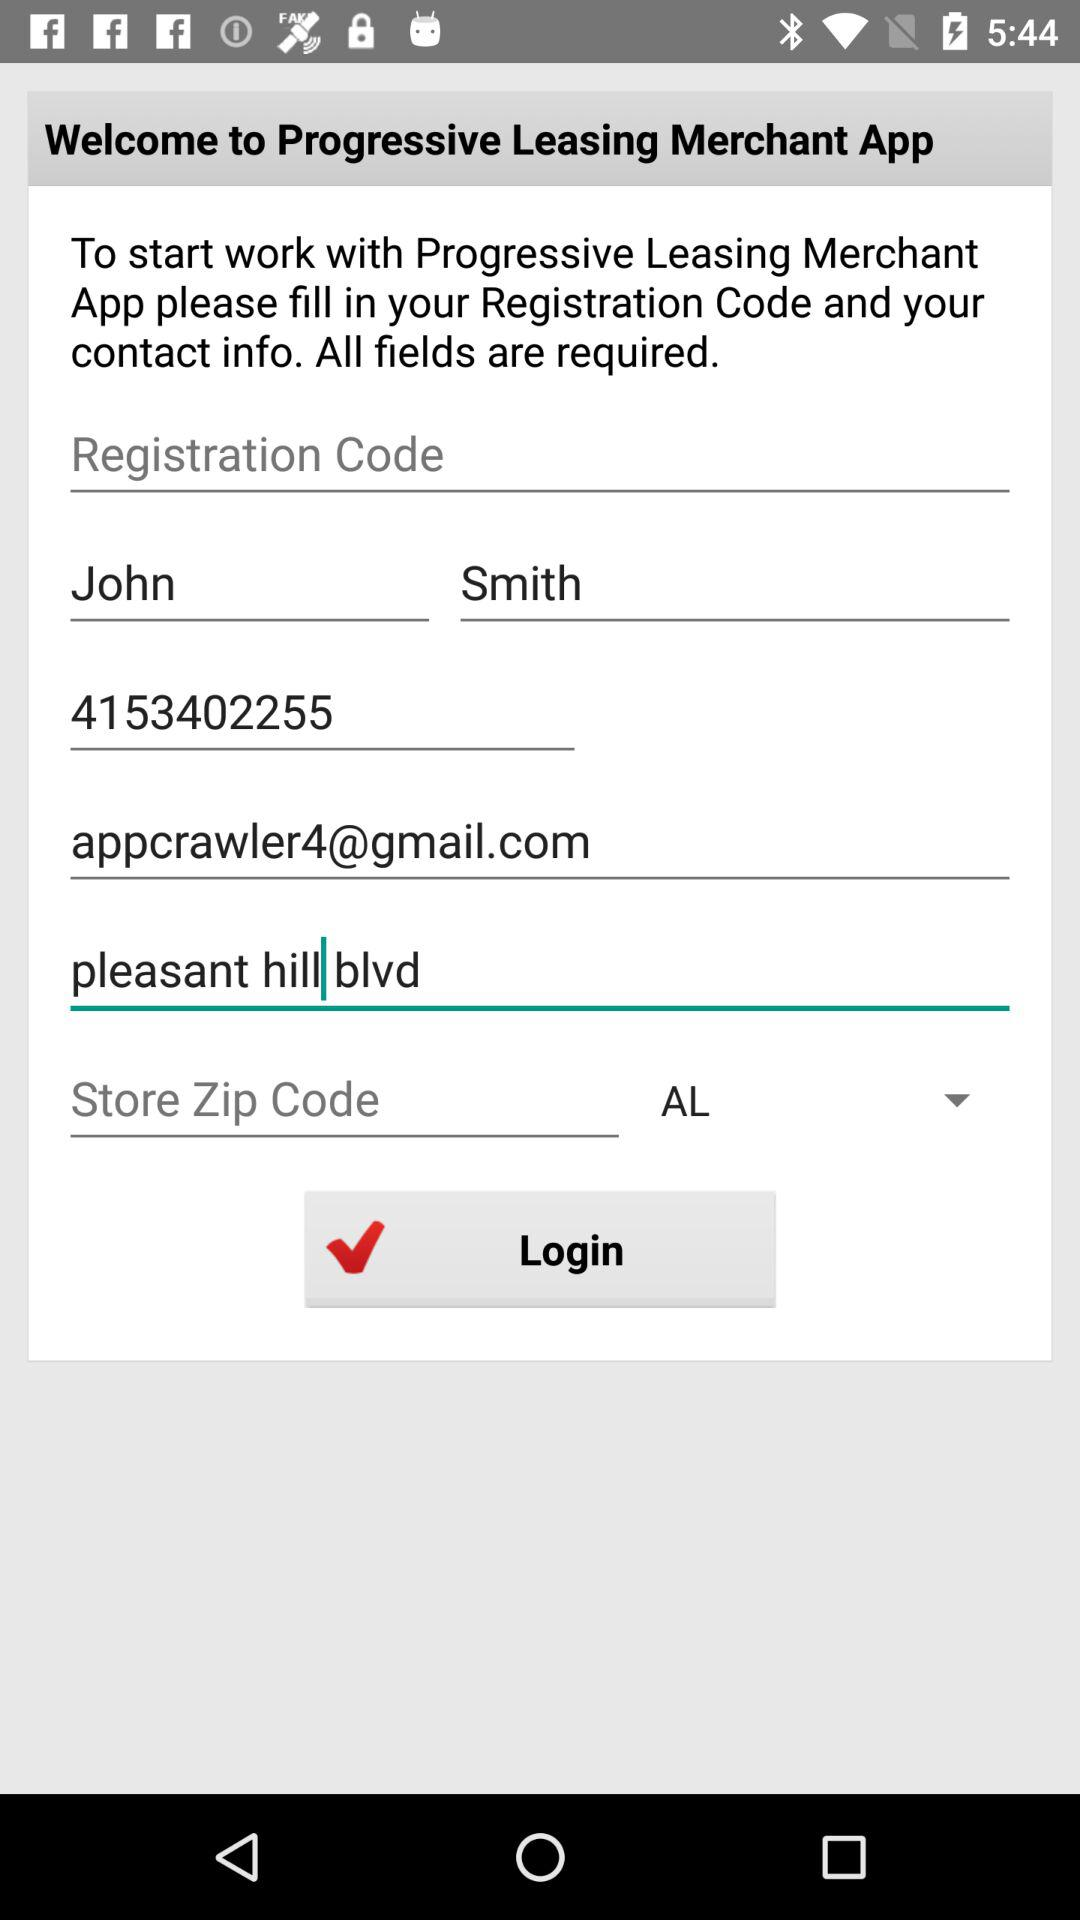What is the user name? The user name is John Smith. 